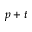<formula> <loc_0><loc_0><loc_500><loc_500>p + t</formula> 